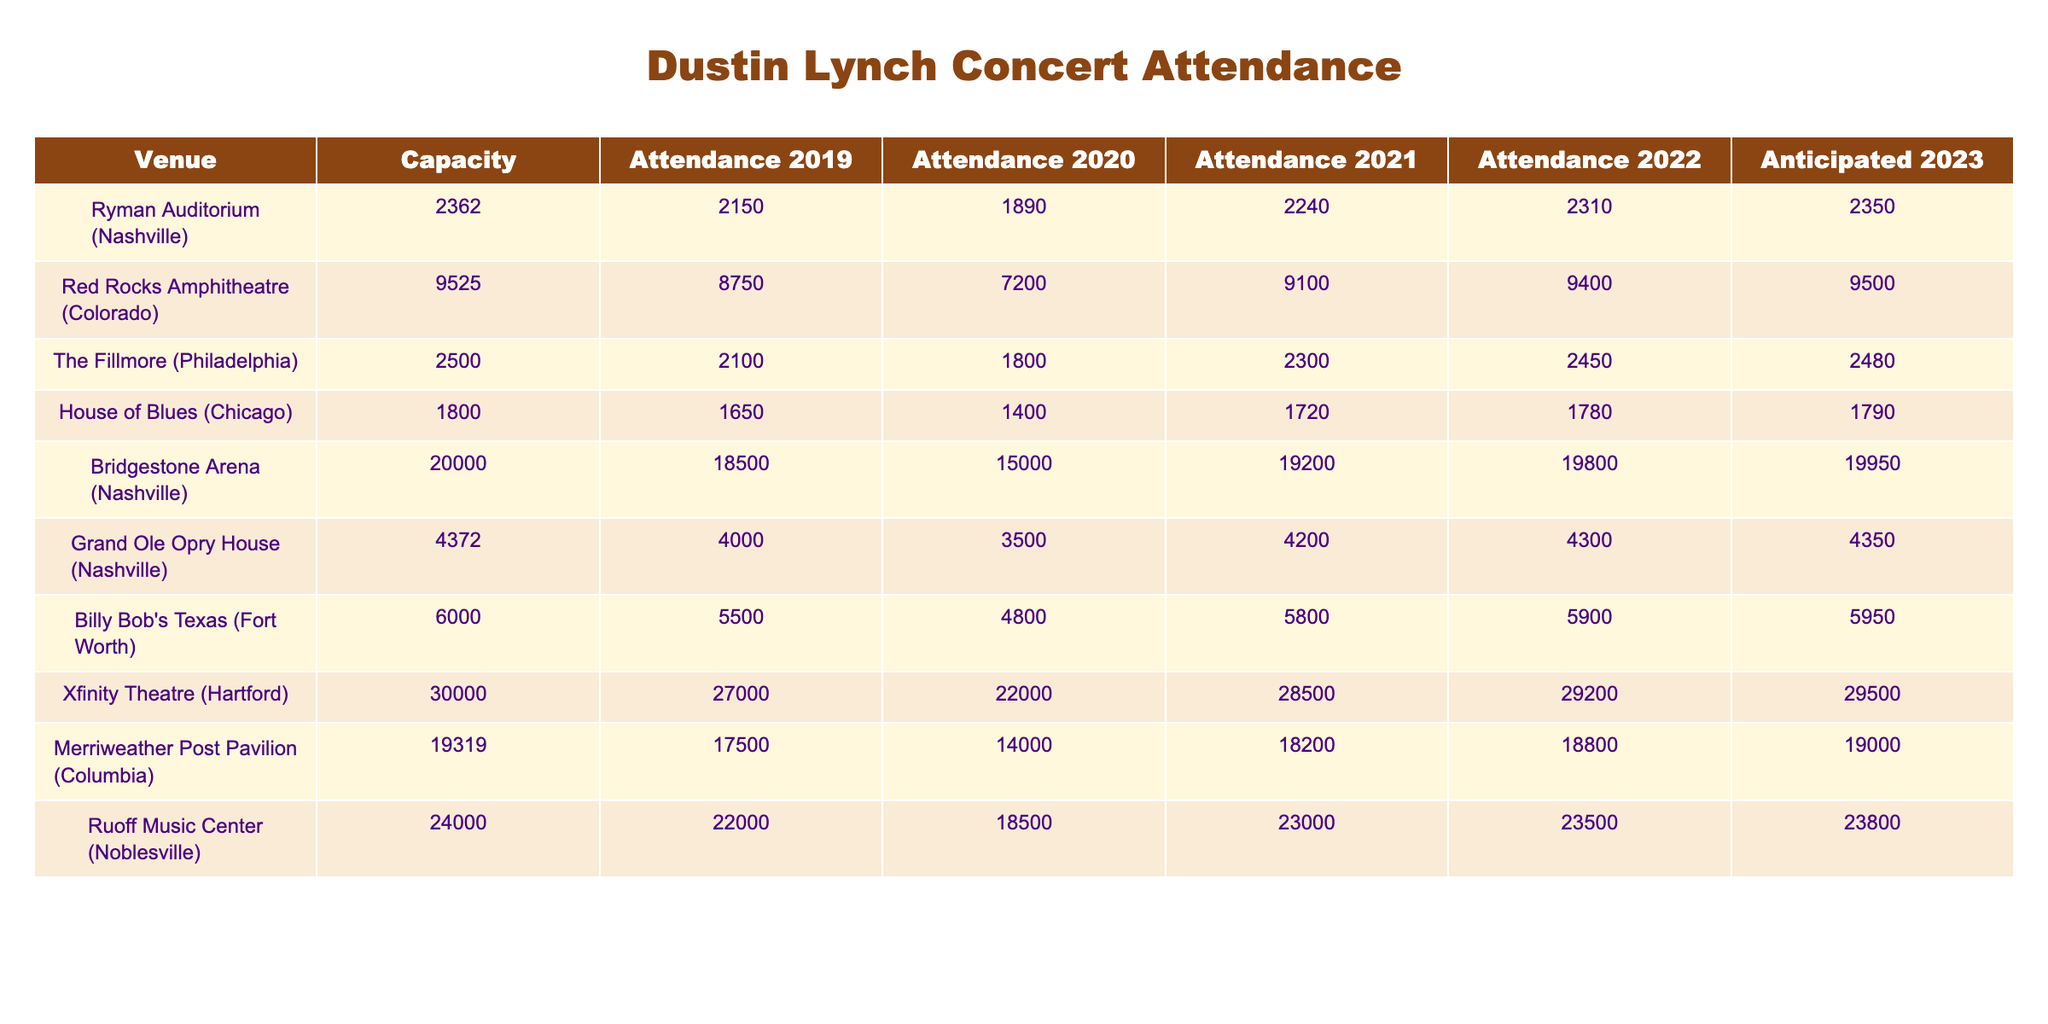What was the attendance at the Ryman Auditorium in 2022? The table shows that the attendance at the Ryman Auditorium (Nashville) in 2022 was 2310.
Answer: 2310 Which venue had the highest attendance in 2019? By examining the table, the highest attendance in 2019 was at the Bridgestone Arena (Nashville) with 18500 attendees.
Answer: 18500 How much did the attendance increase from 2021 to 2022 at the Fillmore? The attendance at the Fillmore (Philadelphia) in 2021 was 2300, and in 2022 it was 2450. The increase is calculated as: 2450 - 2300 = 150.
Answer: 150 What is the anticipated attendance for 2023 at the Grand Ole Opry House? The table indicates that the anticipated attendance for 2023 at the Grand Ole Opry House (Nashville) is 4350.
Answer: 4350 Did attendance at Billy Bob's Texas increase every year from 2019 to 2022? Looking at the attendance figures: 2019: 5500, 2020: 4800 (decrease), 2021: 5800 (increase), 2022: 5900 (increase). Since there was a decrease in 2020, the statement is false.
Answer: No Which venue had the least attendance in 2020? The attendance figures for 2020 show that the House of Blues (Chicago) had the least attendance at 1400 attendees.
Answer: 1400 What is the difference in anticipated attendance between the Xfinity Theatre and the Merriweather Post Pavilion for 2023? The anticipated attendance for the Xfinity Theatre is 29500 and for the Merriweather Post Pavilion is 19000. The difference is calculated as: 29500 - 19000 = 10500.
Answer: 10500 How does the 2022 attendance compare to the 2019 attendance at Ruoff Music Center? The attendance in 2019 was 22000, and in 2022, it was 23000. The increase is 23000 - 22000 = 1000. Therefore, it increased from 2019 to 2022.
Answer: Increased by 1000 Which venue experienced the greatest decrease in attendance from 2019 to 2020? Comparing the years, the venue with the greatest decrease is Bridgestone Arena where attendance fell from 18500 (2019) to 15000 (2020), a decrease of 3500.
Answer: 3500 What was the average attendance over the years 2021 to 2022 for the Red Rocks Amphitheatre? The attendance figures for 2021 and 2022 are 7200 and 9100, respectively. The average is calculated as: (7200 + 9100) / 2 = 8150.
Answer: 8150 